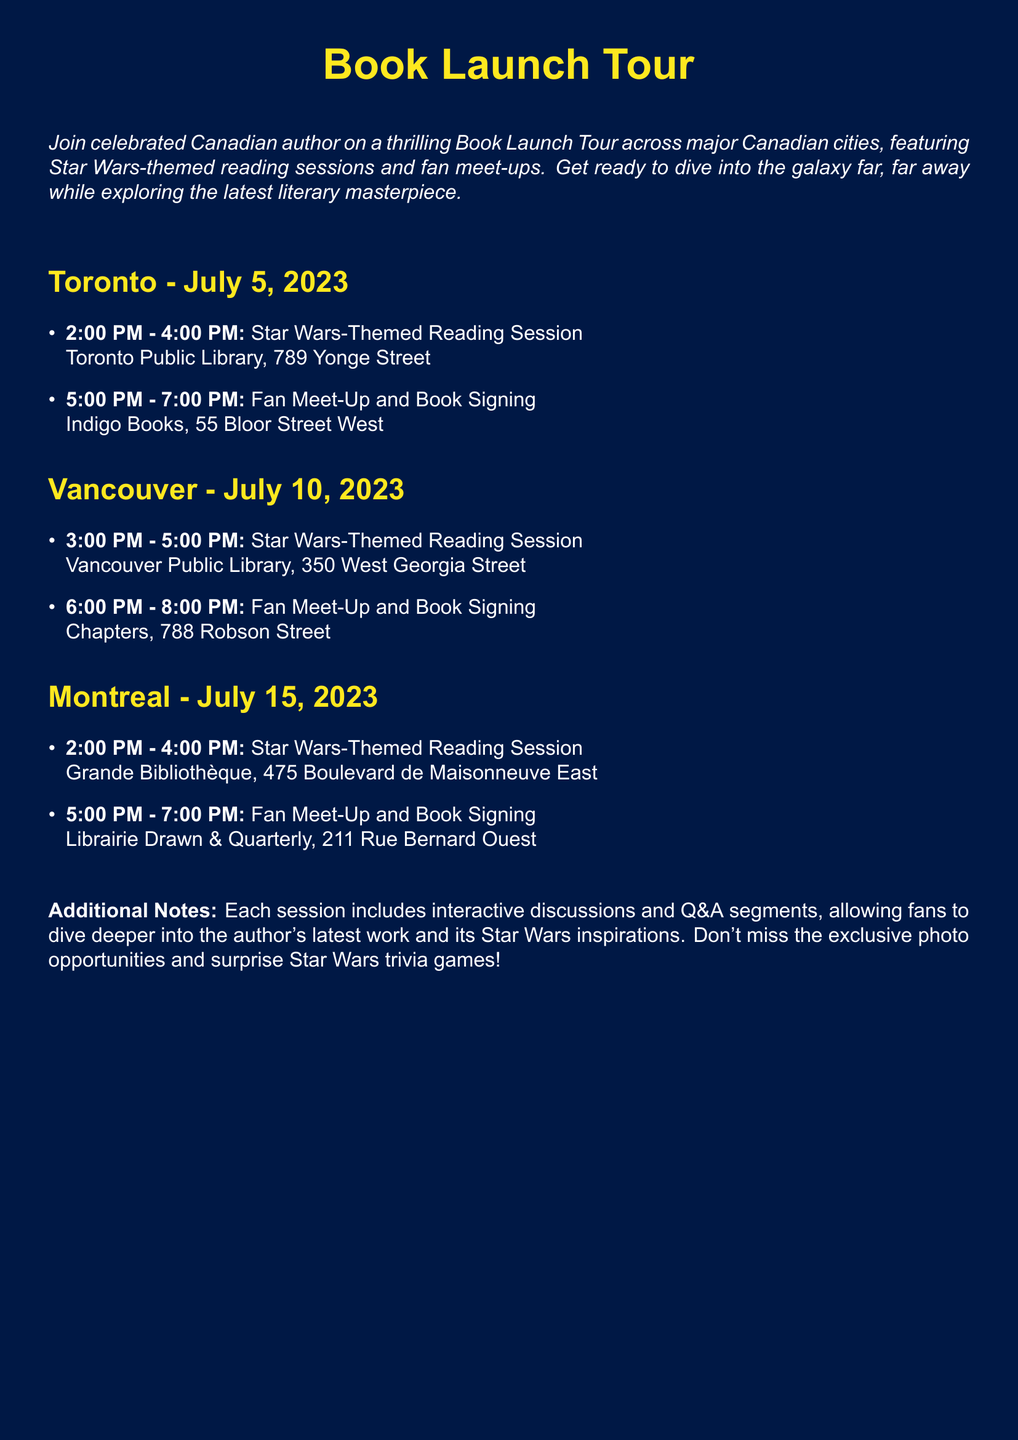What is the date of the Toronto event? The Toronto event is scheduled for July 5, 2023.
Answer: July 5, 2023 Where is the Fan Meet-Up in Vancouver taking place? The Fan Meet-Up in Vancouver is located at Chapters, 788 Robson Street.
Answer: Chapters, 788 Robson Street What time does the Star Wars-Themed Reading Session in Montreal start? The reading session in Montreal begins at 2:00 PM.
Answer: 2:00 PM How long is each Star Wars-Themed Reading Session? The reading sessions are scheduled for 2 hours each, from 2:00 PM to 4:00 PM or 3:00 PM to 5:00 PM.
Answer: 2 hours What type of events are planned at each location? Each location features Star Wars-Themed Reading Sessions and Fan Meet-Ups.
Answer: Star Wars-Themed Reading Sessions and Fan Meet-Ups What is the address of the Toronto Public Library? The Toronto Public Library is located at 789 Yonge Street.
Answer: 789 Yonge Street How many cities are included in the Book Launch Tour? The Book Launch Tour includes three major Canadian cities.
Answer: Three What is one of the interactive components of the sessions? The sessions include interactive discussions and Q&A segments.
Answer: Interactive discussions and Q&A segments What is featured alongside the Book Signings? Exclusive photo opportunities and surprise Star Wars trivia games are featured alongside the Book Signings.
Answer: Exclusive photo opportunities and surprise Star Wars trivia games 